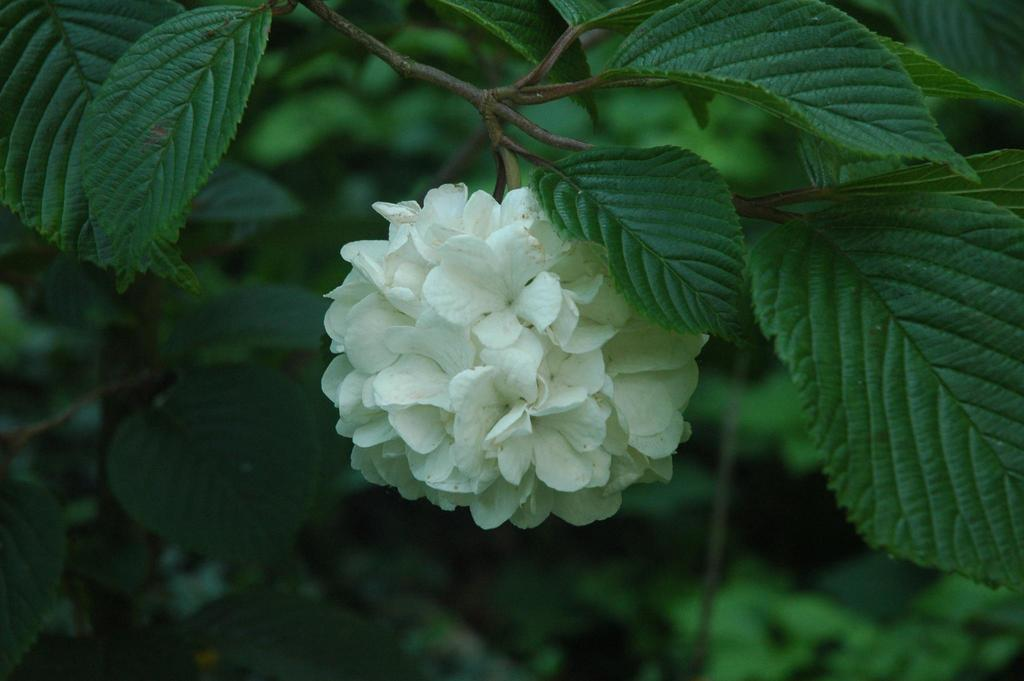What type of flowers can be seen in the image? There are white color flowers in the image. Where are the flowers located in the image? The flowers are in the middle of the image. What else can be seen in the image besides the flowers? There are leaves of a plant in the image. What type of chin can be seen on the baby in the image? There is no baby or chin present in the image; it features white color flowers and leaves of a plant. 